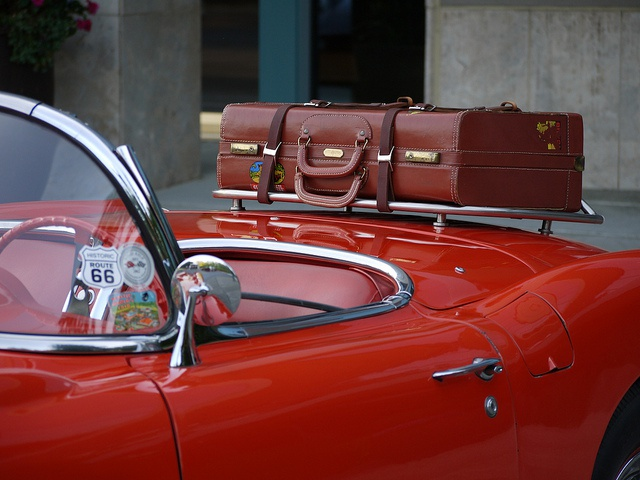Describe the objects in this image and their specific colors. I can see car in black, brown, and maroon tones and suitcase in black, maroon, and brown tones in this image. 